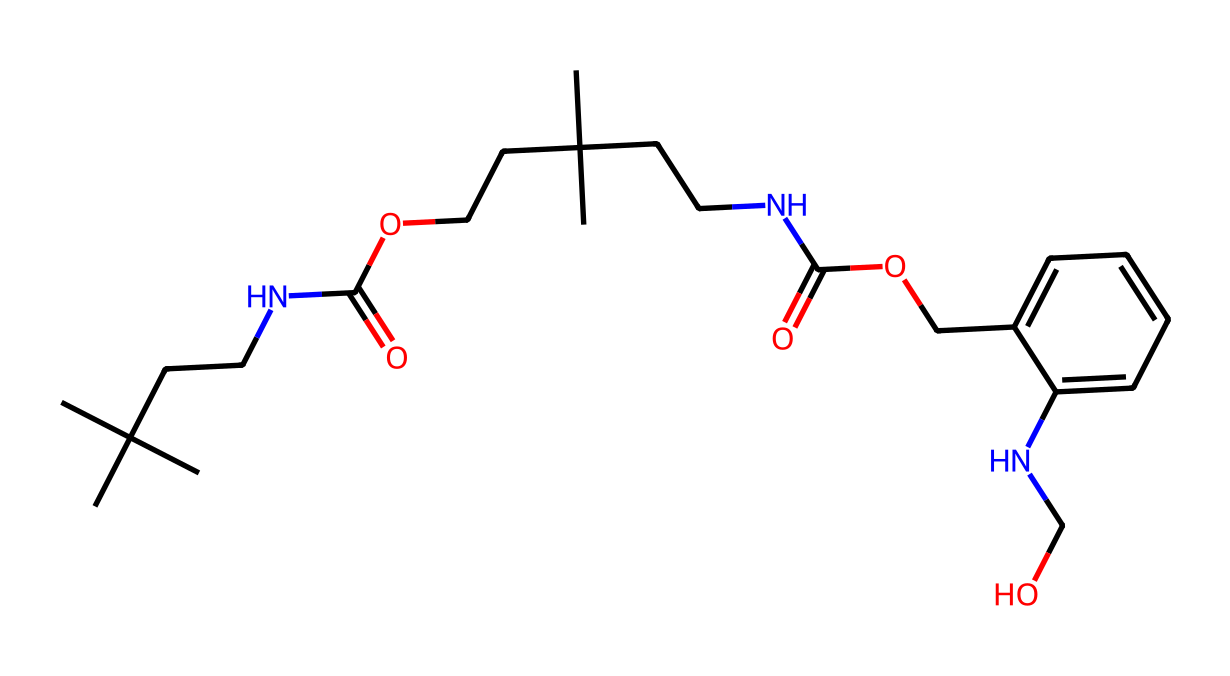How many nitrogen atoms are present in this chemical? By inspecting the SMILES representation, we can count the number of nitrogen (N) symbols. In this specific structure, there are two distinct nitrogen atoms indicated in the sequence, which shows there are two instances of "N".
Answer: two What type of functional group is observed in this chemical? The structure contains multiple instances of the amide group, characterized by the "NC(=O)" notation indicating nitrogen bonded to a carbonyl group. This is a typical feature of polyurethanes.
Answer: amide How many carbon atoms are in this chemical? To count the carbon atoms, we can look for the "C" symbols in the SMILES representation. Upon careful scrutiny, we note that there are twelve carbon atoms present.
Answer: twelve What is the primary use of a chemical like this? Considering the structure's resemblance to polyurethane components and its application, the main use of this compound is in soundproofing, particularly in studio environments.
Answer: soundproofing Describe the type of polymer this represents. The structure features repeating units with urethane linkages (CO-NH), characteristic of polyurethanes. This indicates it is a polymer formed by the reaction of an alcohol with diisocyanates.
Answer: polyurethane What gives this chemical its flexibility in applications? The branched aliphatic structure, including multiple alkyl groups and the urethane linkages, contributes to its flexibility and also aids in energy absorption, making it suitable for various applications including cushioning and soundproofing.
Answer: branched aliphatic structure Is this chemical typically rigid or flexible? The presence of flexible urethane linkages in its structure along with aliphatic chains points towards a softer, more flexible type of foam, typical of those used in soundproof applications.
Answer: flexible 